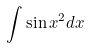<formula> <loc_0><loc_0><loc_500><loc_500>\int \sin x ^ { 2 } d x</formula> 